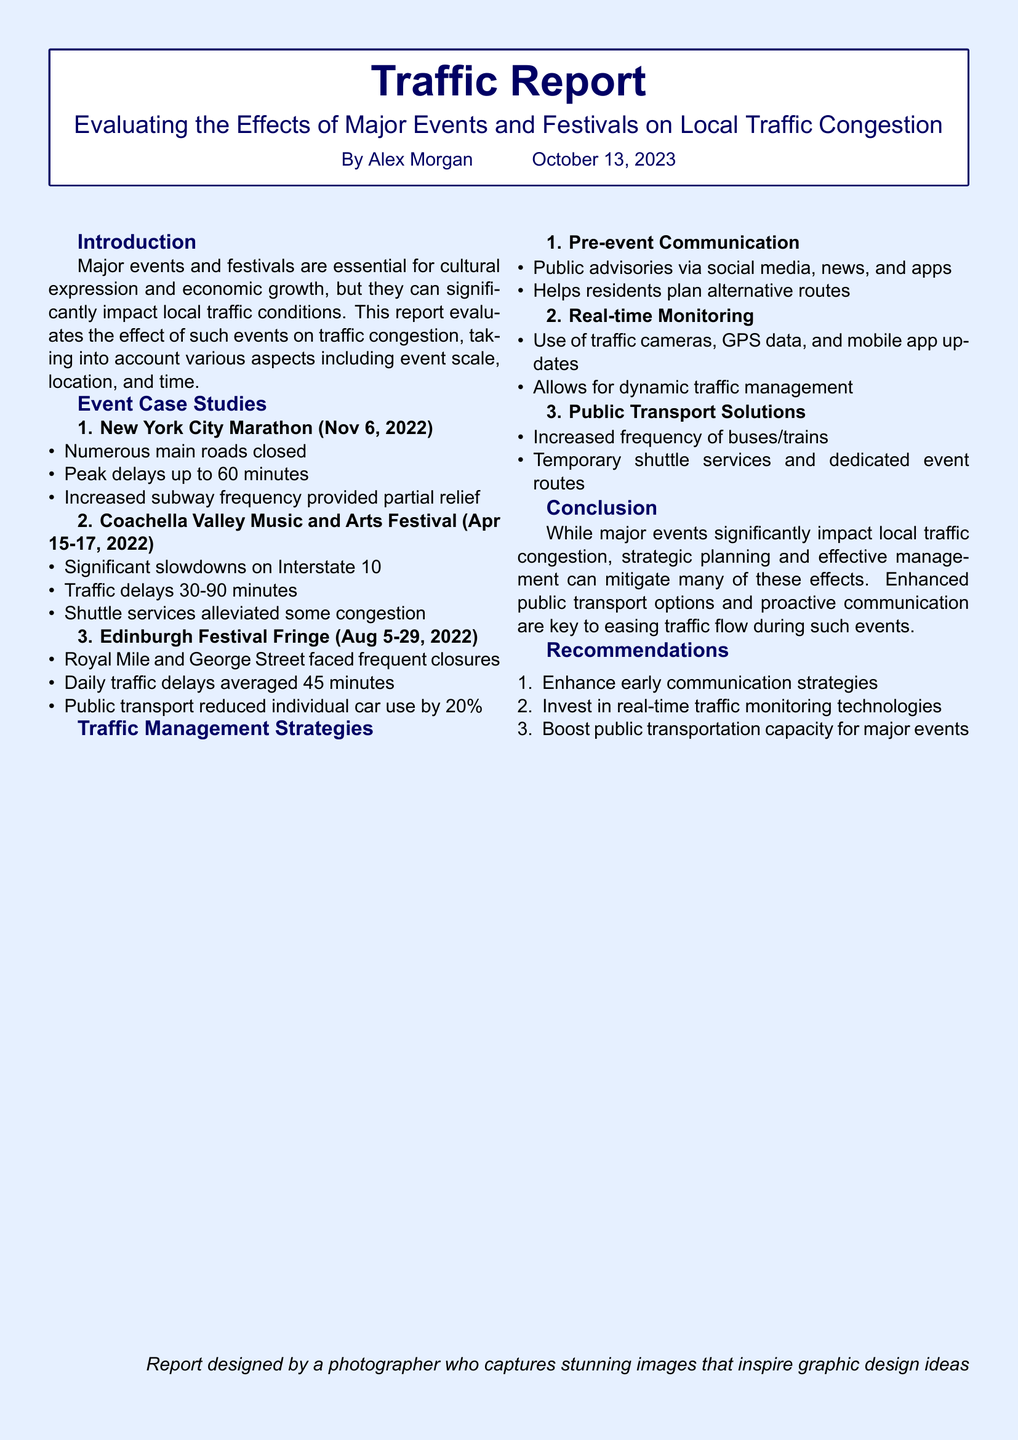What is the title of the report? The title of the report is presented in the header of the document.
Answer: Traffic Report When was the New York City Marathon held? The date of the event is mentioned in the case study section.
Answer: Nov 6, 2022 What was the peak delay reported for the New York City Marathon? The peak delay is specified in the event case study details.
Answer: 60 minutes What percentage did public transport reduce individual car use by during the Edinburgh Festival Fringe? This percentage is mentioned in the summary of the event case studies.
Answer: 20% What is one traffic management strategy mentioned in the report? The strategies are listed under the Traffic Management Strategies section.
Answer: Pre-event Communication How long did traffic delays last during the Coachella Valley Music and Arts Festival? The delays for this event are detailed in the corresponding case study.
Answer: 30-90 minutes What was a recommendation regarding public transportation? Recommendations are listed in that section of the report.
Answer: Boost public transportation capacity for major events What did the report evaluate? The focus of the report is outlined in the introduction.
Answer: Effects of Major Events and Festivals on Local Traffic Congestion 